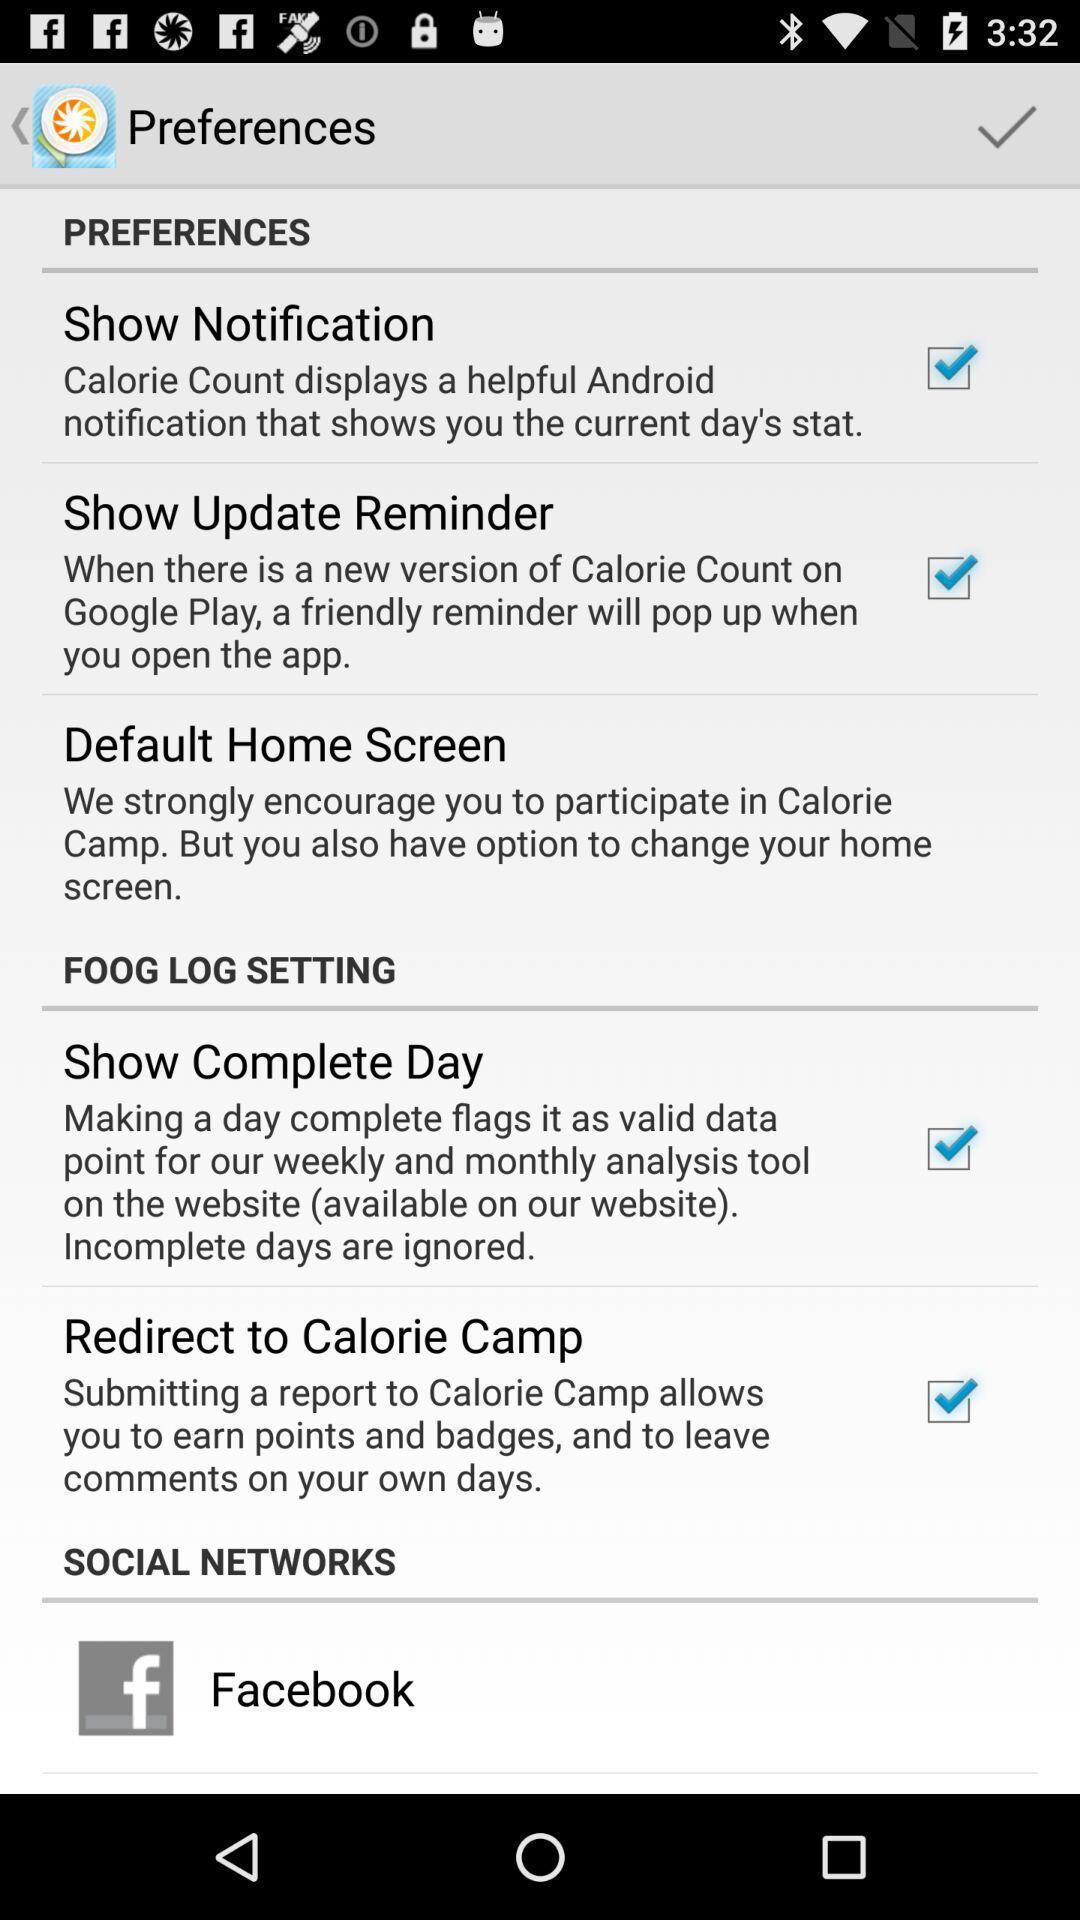What can you discern from this picture? Settings page. 